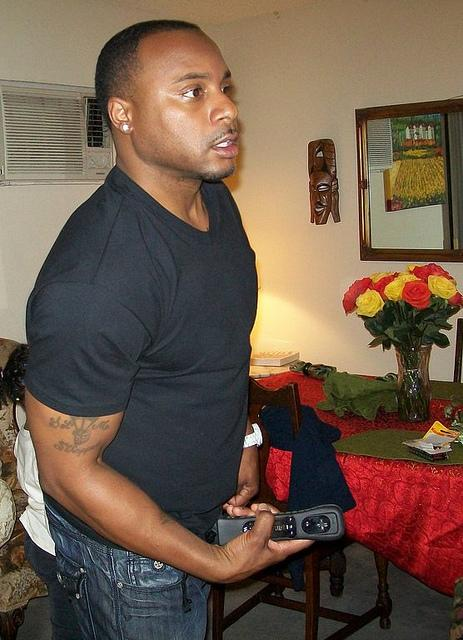The remote is meant to communicate with what? television 